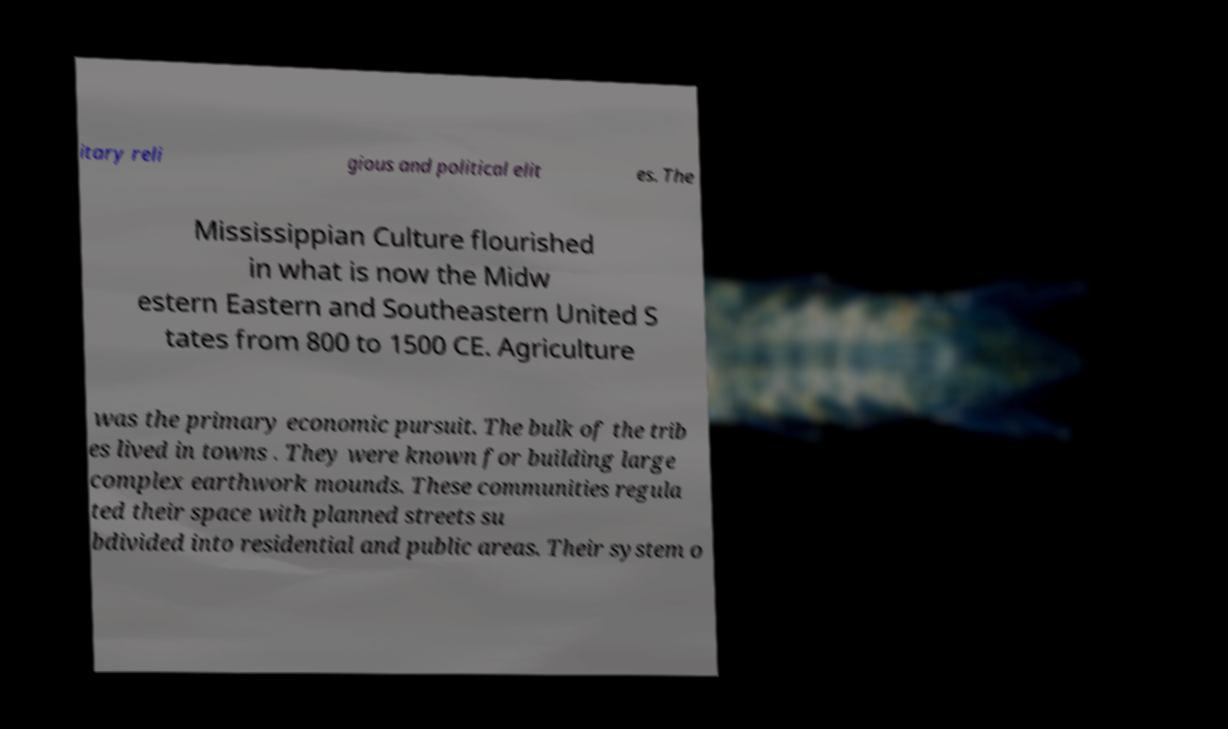Could you extract and type out the text from this image? itary reli gious and political elit es. The Mississippian Culture flourished in what is now the Midw estern Eastern and Southeastern United S tates from 800 to 1500 CE. Agriculture was the primary economic pursuit. The bulk of the trib es lived in towns . They were known for building large complex earthwork mounds. These communities regula ted their space with planned streets su bdivided into residential and public areas. Their system o 